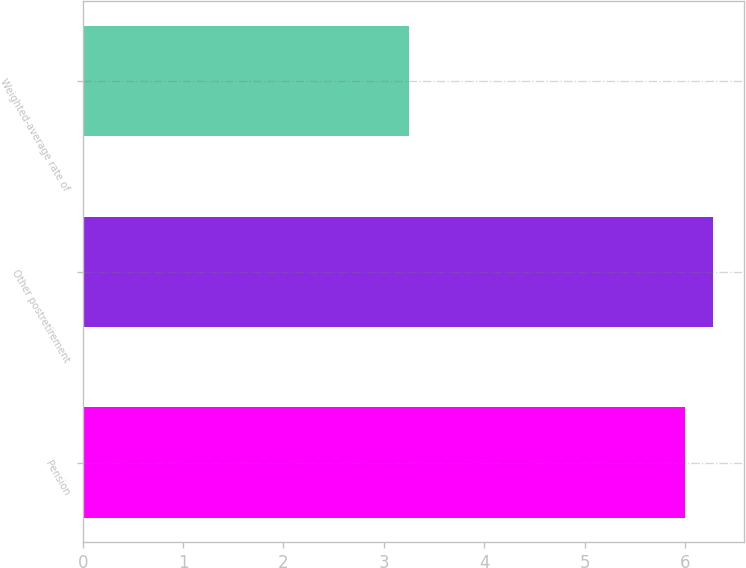Convert chart to OTSL. <chart><loc_0><loc_0><loc_500><loc_500><bar_chart><fcel>Pension<fcel>Other postretirement<fcel>Weighted-average rate of<nl><fcel>6<fcel>6.28<fcel>3.25<nl></chart> 